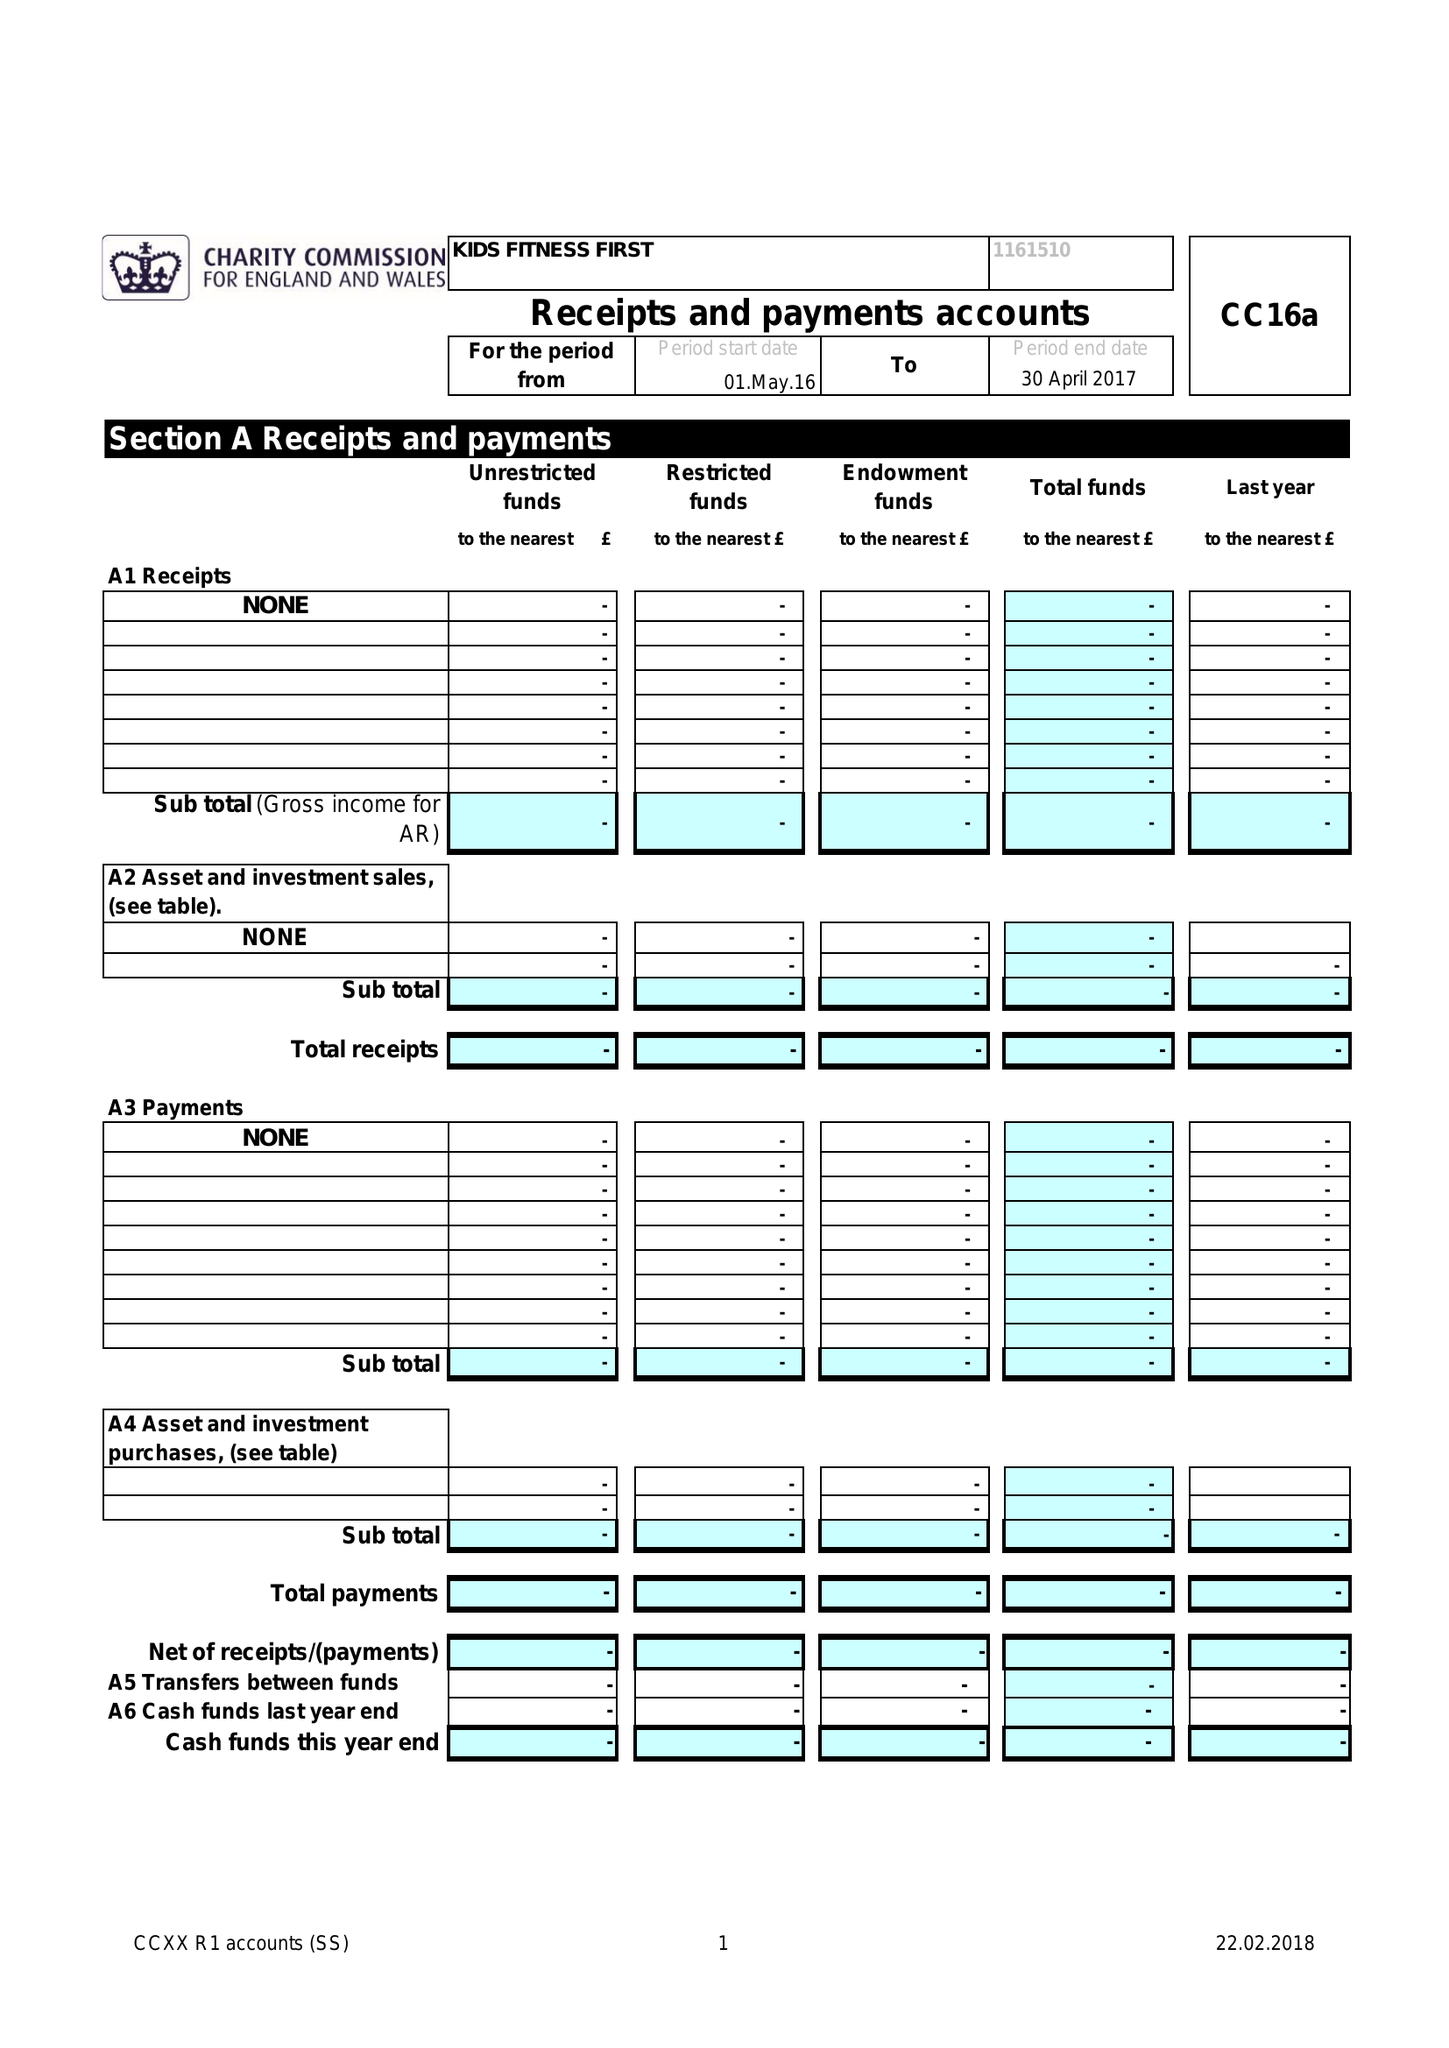What is the value for the address__postcode?
Answer the question using a single word or phrase. M4 6DE 